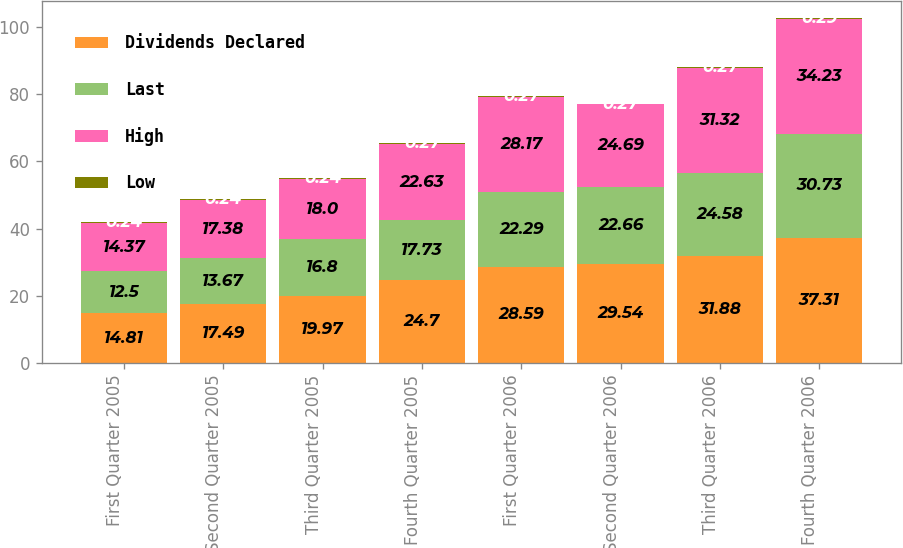<chart> <loc_0><loc_0><loc_500><loc_500><stacked_bar_chart><ecel><fcel>First Quarter 2005<fcel>Second Quarter 2005<fcel>Third Quarter 2005<fcel>Fourth Quarter 2005<fcel>First Quarter 2006<fcel>Second Quarter 2006<fcel>Third Quarter 2006<fcel>Fourth Quarter 2006<nl><fcel>Dividends Declared<fcel>14.81<fcel>17.49<fcel>19.97<fcel>24.7<fcel>28.59<fcel>29.54<fcel>31.88<fcel>37.31<nl><fcel>Last<fcel>12.5<fcel>13.67<fcel>16.8<fcel>17.73<fcel>22.29<fcel>22.66<fcel>24.58<fcel>30.73<nl><fcel>High<fcel>14.37<fcel>17.38<fcel>18<fcel>22.63<fcel>28.17<fcel>24.69<fcel>31.32<fcel>34.23<nl><fcel>Low<fcel>0.24<fcel>0.24<fcel>0.24<fcel>0.27<fcel>0.27<fcel>0.27<fcel>0.27<fcel>0.29<nl></chart> 